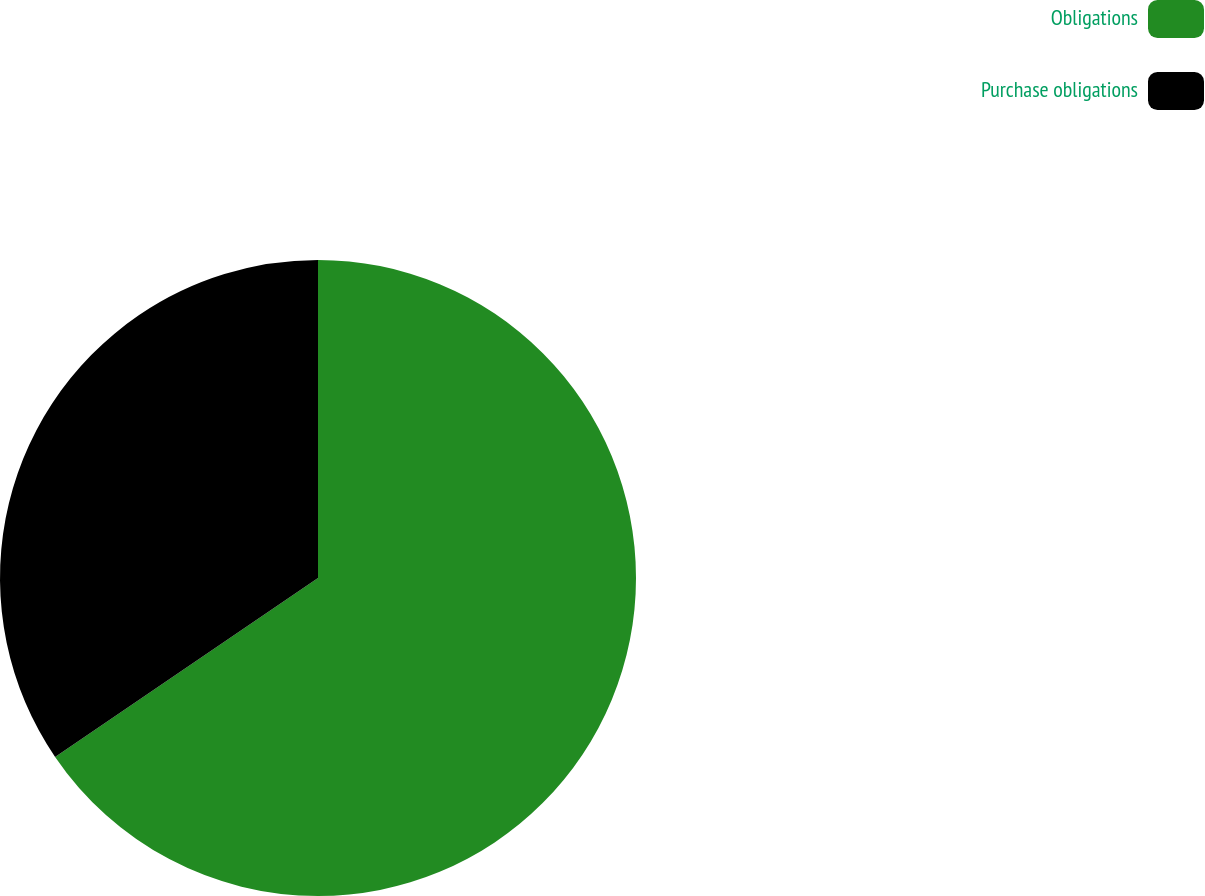Convert chart. <chart><loc_0><loc_0><loc_500><loc_500><pie_chart><fcel>Obligations<fcel>Purchase obligations<nl><fcel>65.49%<fcel>34.51%<nl></chart> 